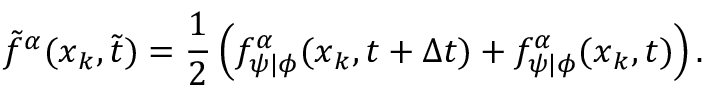Convert formula to latex. <formula><loc_0><loc_0><loc_500><loc_500>\tilde { f } ^ { \alpha } ( x _ { k } , \tilde { t } ) = \frac { 1 } { 2 } \left ( f _ { \psi | \phi } ^ { \alpha } ( x _ { k } , t + \Delta { t } ) + f _ { \psi | \phi } ^ { \alpha } ( x _ { k } , t ) \right ) .</formula> 